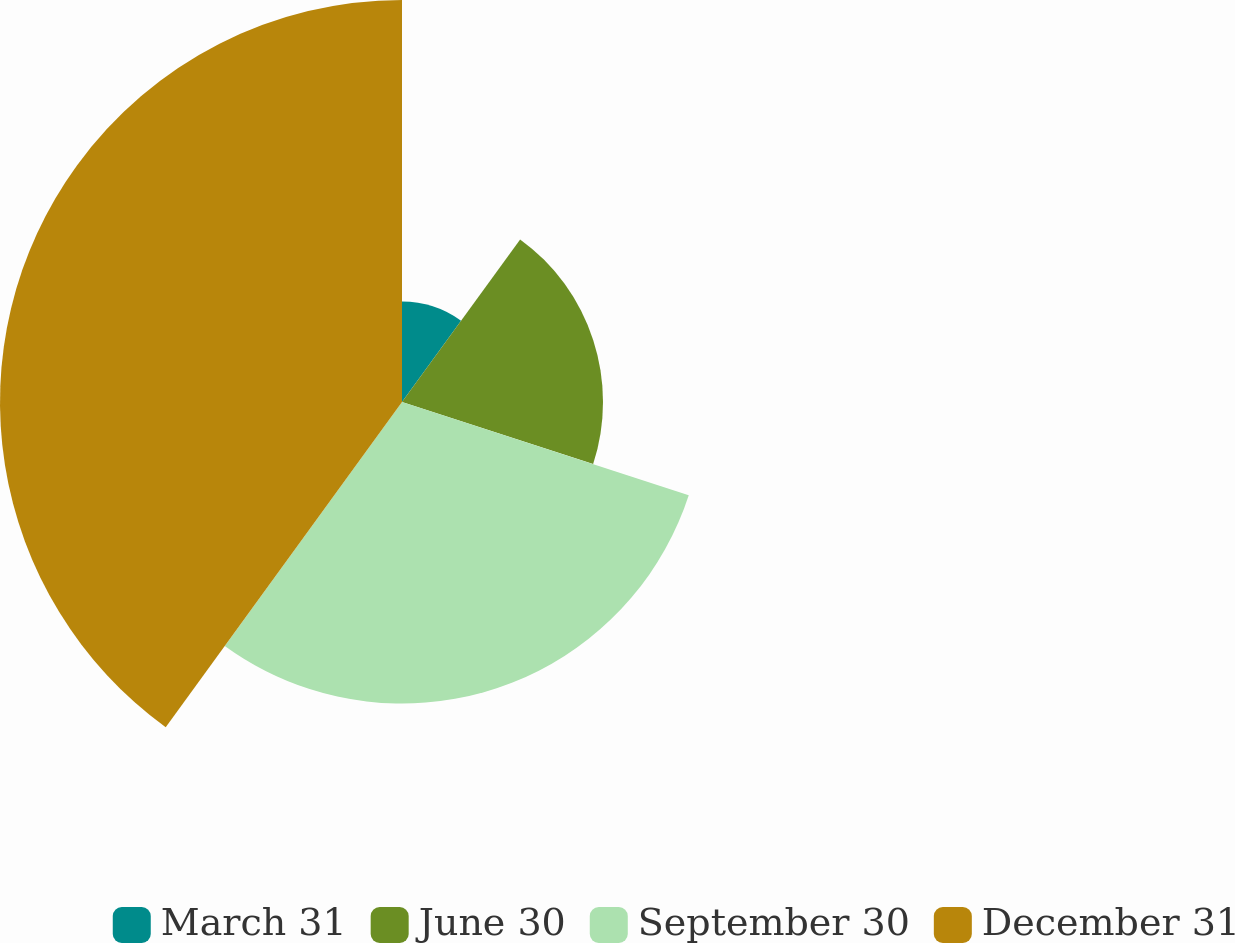Convert chart to OTSL. <chart><loc_0><loc_0><loc_500><loc_500><pie_chart><fcel>March 31<fcel>June 30<fcel>September 30<fcel>December 31<nl><fcel>10.0%<fcel>20.0%<fcel>30.0%<fcel>40.0%<nl></chart> 